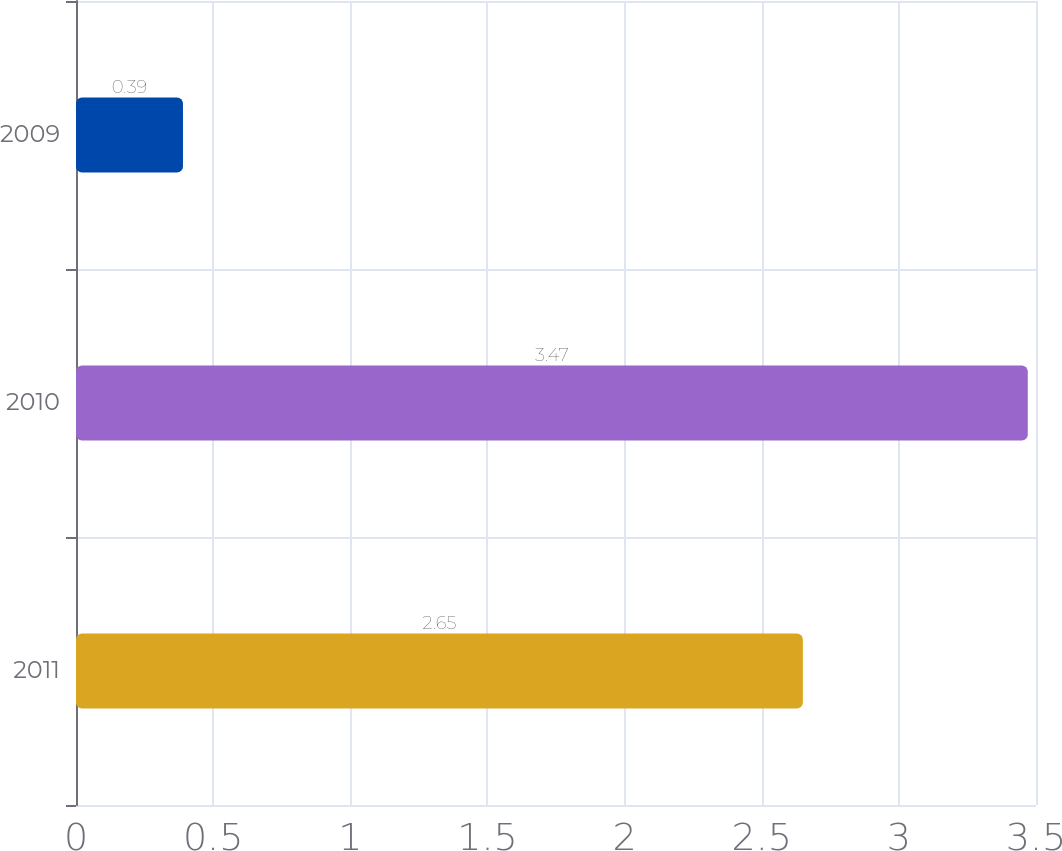Convert chart. <chart><loc_0><loc_0><loc_500><loc_500><bar_chart><fcel>2011<fcel>2010<fcel>2009<nl><fcel>2.65<fcel>3.47<fcel>0.39<nl></chart> 